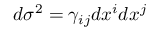<formula> <loc_0><loc_0><loc_500><loc_500>d \sigma ^ { 2 } = \gamma _ { i j } d x ^ { i } d x ^ { j }</formula> 